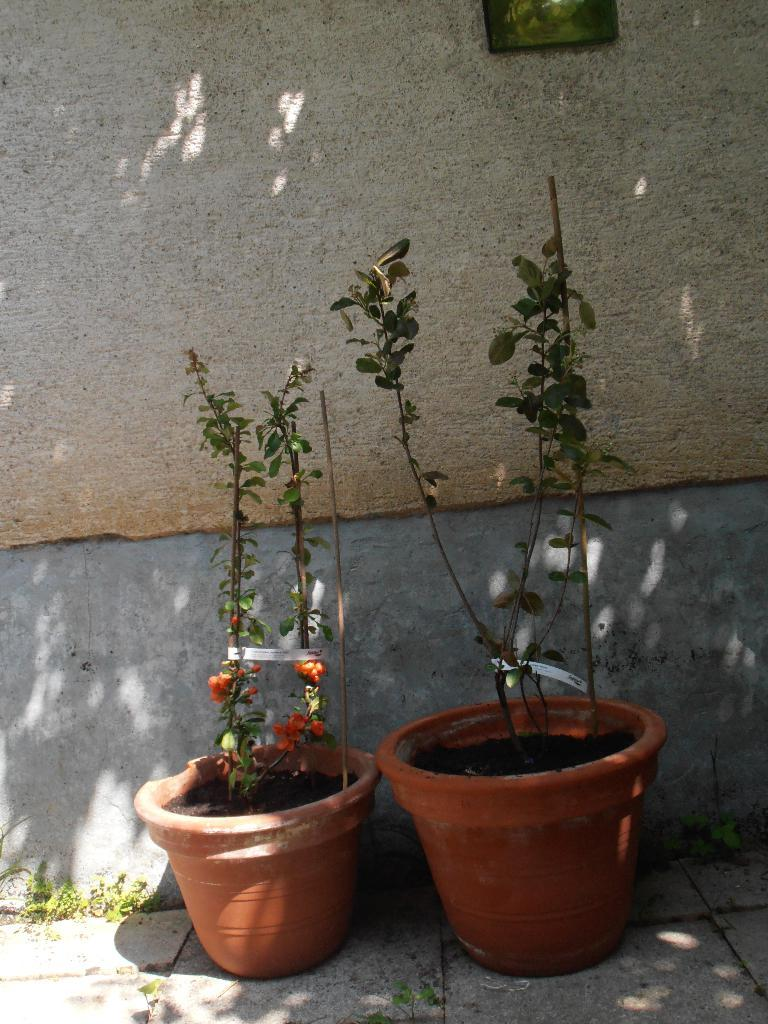What is present in the flower pots in the image? There are plants in the flower pots in the image. What can be seen in the background of the image? There is a wall in the background of the image. What is placed on the wall in the background of the image? There is a frame placed on the wall in the background of the image. What is the view like from the downtown area in the image? There is no downtown area or view mentioned in the image; it only features plants in flower pots, a wall, and a frame. 